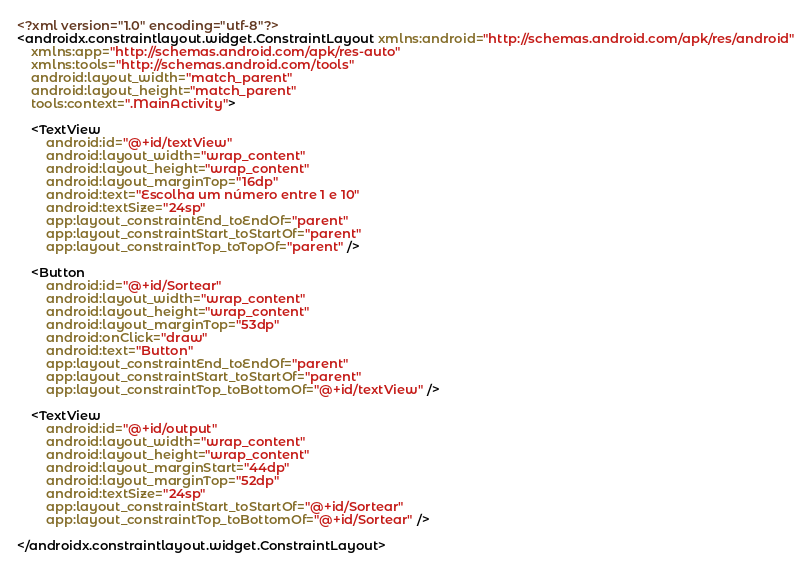Convert code to text. <code><loc_0><loc_0><loc_500><loc_500><_XML_><?xml version="1.0" encoding="utf-8"?>
<androidx.constraintlayout.widget.ConstraintLayout xmlns:android="http://schemas.android.com/apk/res/android"
    xmlns:app="http://schemas.android.com/apk/res-auto"
    xmlns:tools="http://schemas.android.com/tools"
    android:layout_width="match_parent"
    android:layout_height="match_parent"
    tools:context=".MainActivity">

    <TextView
        android:id="@+id/textView"
        android:layout_width="wrap_content"
        android:layout_height="wrap_content"
        android:layout_marginTop="16dp"
        android:text="Escolha um número entre 1 e 10"
        android:textSize="24sp"
        app:layout_constraintEnd_toEndOf="parent"
        app:layout_constraintStart_toStartOf="parent"
        app:layout_constraintTop_toTopOf="parent" />

    <Button
        android:id="@+id/Sortear"
        android:layout_width="wrap_content"
        android:layout_height="wrap_content"
        android:layout_marginTop="53dp"
        android:onClick="draw"
        android:text="Button"
        app:layout_constraintEnd_toEndOf="parent"
        app:layout_constraintStart_toStartOf="parent"
        app:layout_constraintTop_toBottomOf="@+id/textView" />

    <TextView
        android:id="@+id/output"
        android:layout_width="wrap_content"
        android:layout_height="wrap_content"
        android:layout_marginStart="44dp"
        android:layout_marginTop="52dp"
        android:textSize="24sp"
        app:layout_constraintStart_toStartOf="@+id/Sortear"
        app:layout_constraintTop_toBottomOf="@+id/Sortear" />

</androidx.constraintlayout.widget.ConstraintLayout></code> 